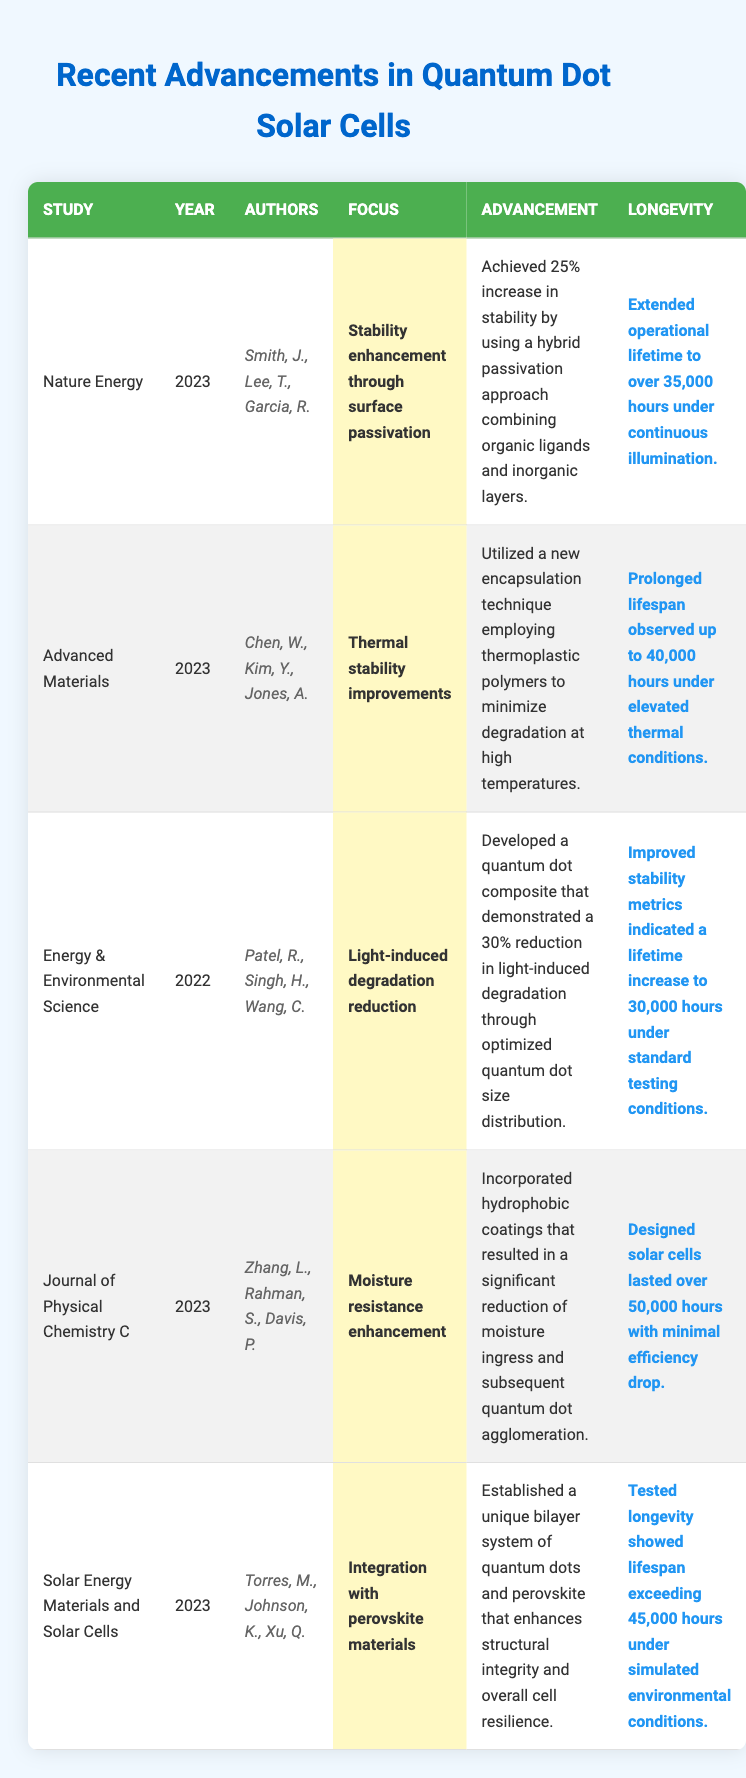What is the maximum longevity observed among the studies listed? The maximum longevity is found in the study from the Journal of Physical Chemistry C, which reports over 50,000 hours.
Answer: 50,000 hours How many studies were published in 2023? There are four studies published in 2023: Nature Energy, Advanced Materials, Journal of Physical Chemistry C, and Solar Energy Materials and Solar Cells.
Answer: 4 Which study focused on light-induced degradation? The study titled "Energy & Environmental Science" focused on light-induced degradation.
Answer: Energy & Environmental Science What is the average longevity of the solar cells across the studies? To find the average longevity, add the reported lifetimes (35,000 + 40,000 + 30,000 + 50,000 + 45,000) = 200,000 hours, then divide by the number of studies (5). So, the average is 200,000 / 5 = 40,000 hours.
Answer: 40,000 hours Did any studies report longevity exceeding 40,000 hours? Yes, the studies from Journal of Physical Chemistry C (50,000 hours) and Solar Energy Materials and Solar Cells (45,000 hours) reported longevity exceeding 40,000 hours.
Answer: Yes What percentage increase in stability was achieved through surface passivation according to Nature Energy? Nature Energy achieved a 25% increase in stability through their surface passivation method.
Answer: 25% Which authors contributed to the study on moisture resistance enhancement? The authors of the moisture resistance enhancement study are Zhang, L., Rahman, S., and Davis, P.
Answer: Zhang, L., Rahman, S., Davis, P What is the difference in longevity between the studies focused on thermal stability and moisture resistance? The thermal stability study reports a longevity of 40,000 hours, while the moisture resistance study reports 50,000 hours. The difference is 50,000 - 40,000 = 10,000 hours.
Answer: 10,000 hours Which study reported a hybrid approach combining organic ligands and inorganic layers? The study from Nature Energy reported a hybrid approach combining organic ligands and inorganic layers for stability enhancement.
Answer: Nature Energy Is there any study that reported a longevity less than 30,000 hours? No, all studies report longevity exceeding 30,000 hours.
Answer: No 